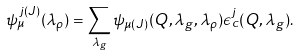<formula> <loc_0><loc_0><loc_500><loc_500>\psi _ { \mu } ^ { \, j ( J ) } ( \lambda _ { \rho } ) = \sum _ { \lambda _ { g } } \psi _ { \mu ( J ) } ( { Q } , \lambda _ { g } , \lambda _ { \rho } ) \epsilon ^ { j } _ { c } ( { Q } , \lambda _ { g } ) .</formula> 